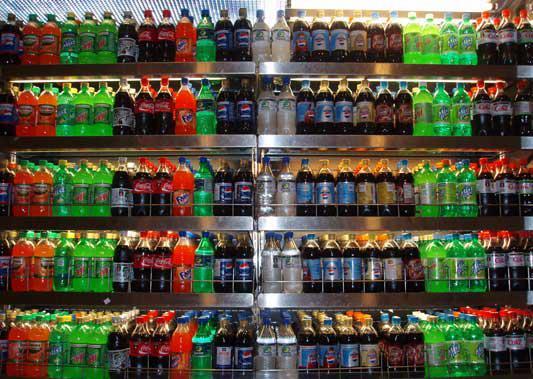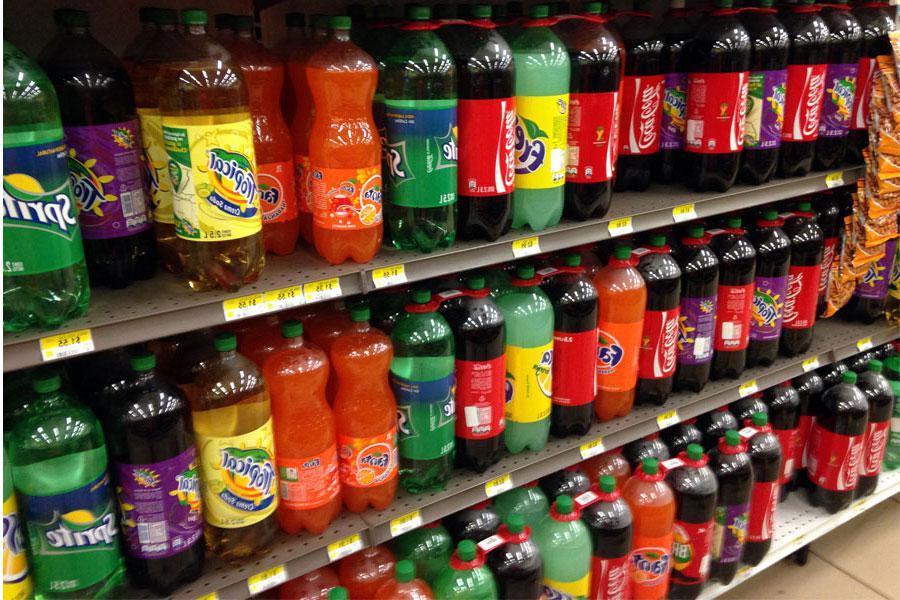The first image is the image on the left, the second image is the image on the right. Examine the images to the left and right. Is the description "There are lots of American brand, plastic soda bottles." accurate? Answer yes or no. Yes. The first image is the image on the left, the second image is the image on the right. For the images shown, is this caption "There are no glass bottles in the right image." true? Answer yes or no. Yes. 